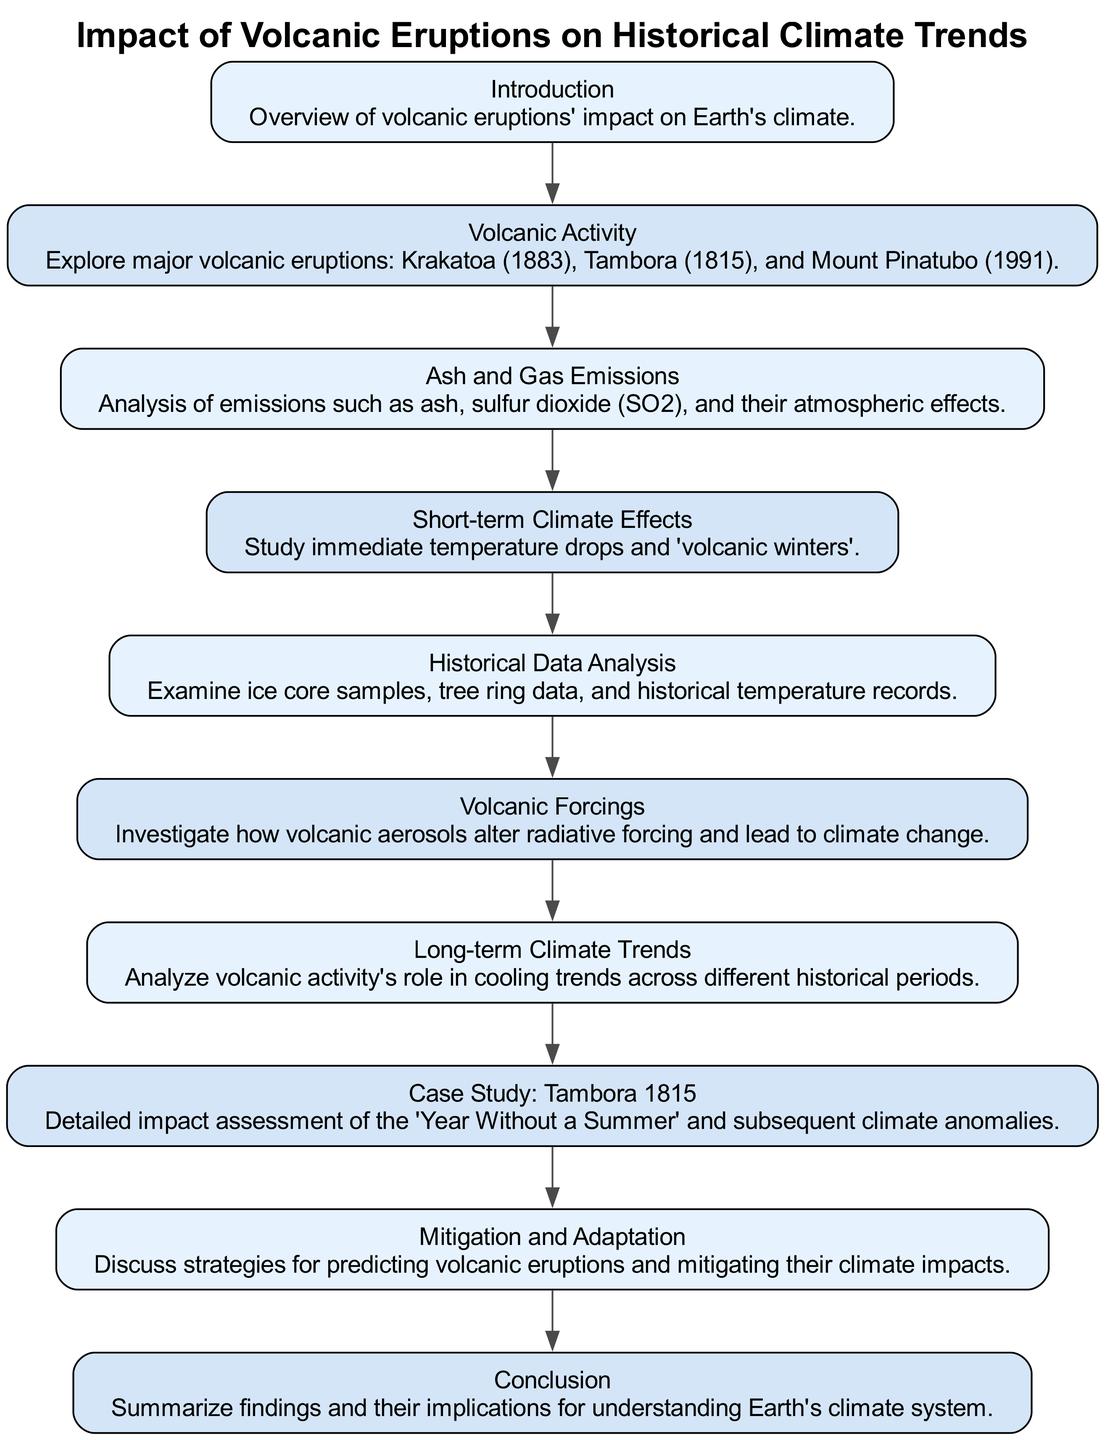What is the title of the clinical pathway? The title is located at the top of the diagram and states the main focus of the pathway. By reading the header that contains the title, we can clearly identify what the clinical pathway is about.
Answer: Impact of Volcanic Eruptions on Historical Climate Trends How many steps are there in the clinical pathway? To determine this, we need to count the number of labeled nodes that represent individual steps. Each unique name in the diagram corresponds to a step, and there are a total of ten distinct steps.
Answer: 10 Which step comes after "Volcanic Activity"? Looking at the order of the steps in the diagram, we see that "Volcanic Activity" is the second step, and the next step flowing from it is labeled "Ash and Gas Emissions."
Answer: Ash and Gas Emissions What is the focus of the step titled "Case Study: Tambora 1815"? The description of this step tells us directly about the specific examination it covers. In this case, it highlights the detailed impacts of a significant historical volcanic event and its climatic effects.
Answer: Detailed impact assessment of the 'Year Without a Summer' and subsequent climate anomalies Which step is directly before "Conclusion"? By moving backward through the flow of the steps in the diagram, we can identify that the step preceding "Conclusion" is "Mitigation and Adaptation."
Answer: Mitigation and Adaptation What is examined in the "Historical Data Analysis" step? The description of this step provides insight into the specific methods being used to gather information on climate trends. It mentions the types of data sources that will be analyzed to assess historical climate impacts.
Answer: Ice core samples, tree ring data, and historical temperature records Which type of volcanic emissions are highlighted in the step "Ash and Gas Emissions"? This step focuses specifically on the emissions from volcanic eruptions. The description specifies a particular gas that is known for its significant impact on climate.
Answer: Sulfur dioxide (SO2) What is the main impact discussed in the "Short-term Climate Effects" step? The description in this step indicates the immediate effects of volcanic eruptions on climate, specifically during a period following an eruption. It references a phenomenon commonly associated with volcanic events.
Answer: Temperature drops and 'volcanic winters' How does "Volcanic Forcings" relate to climate change? The step explains how volcanic activity interacts with climate systems by altering specific environmental factors that affect climate trends, leading to more extended climate changes.
Answer: Alter radiative forcing and lead to climate change What are strategies discussed in the "Mitigation and Adaptation" step? This step addresses potential approaches to deal with the effects of volcanic eruptions on climate, highlighting the need for proactive measures to manage risks associated with these natural events.
Answer: Predicting volcanic eruptions and mitigating their climate impacts 